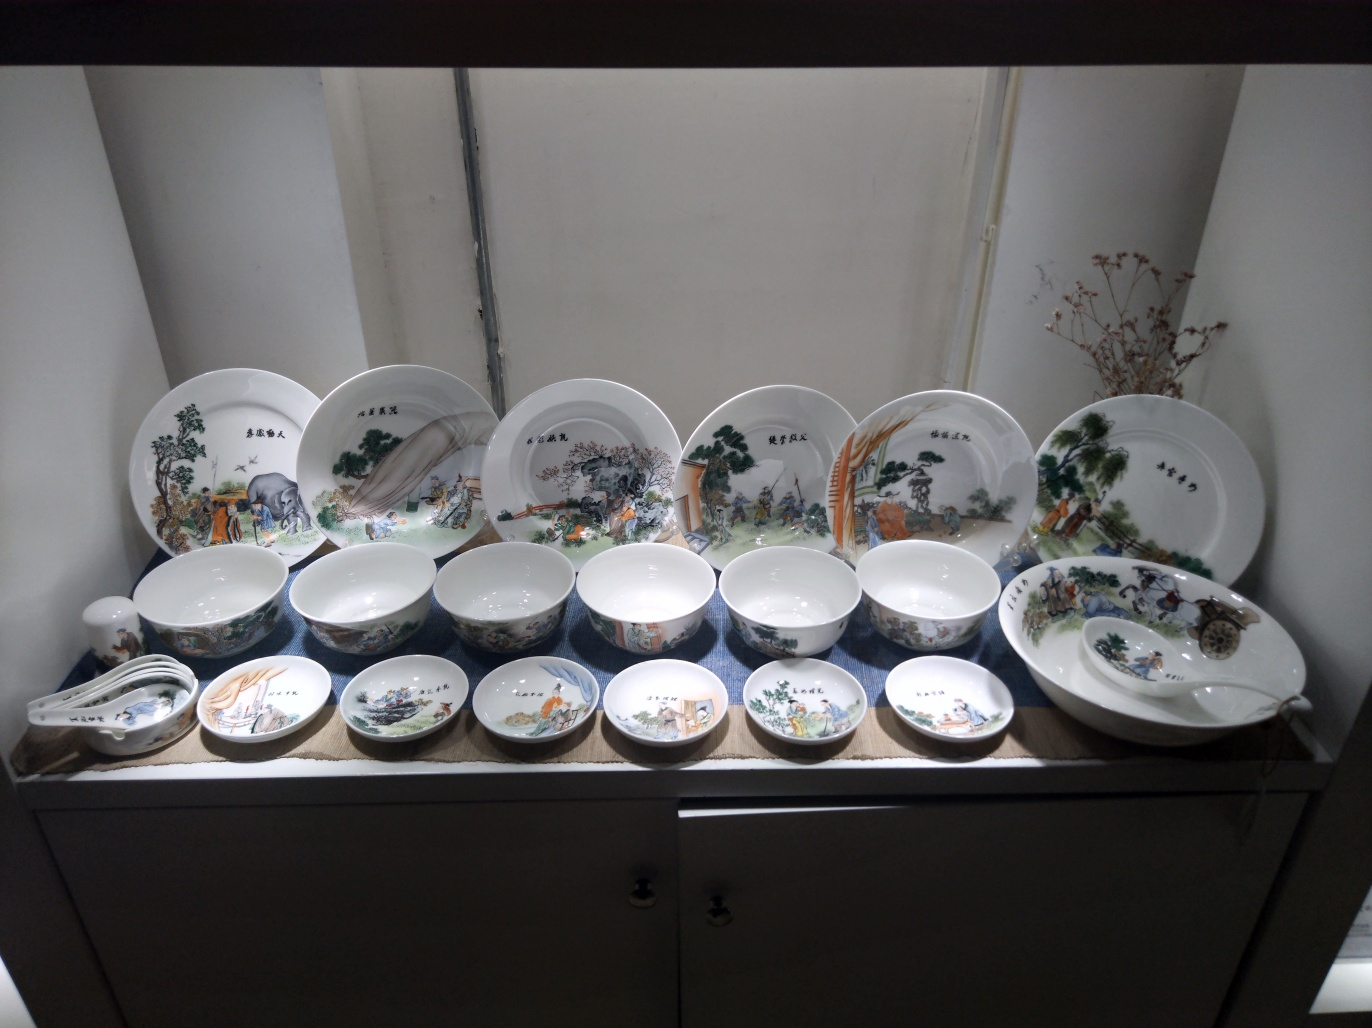Does the photo have a sense of classical beauty?
A. Yes
B. No
Answer with the option's letter from the given choices directly.
 A. 